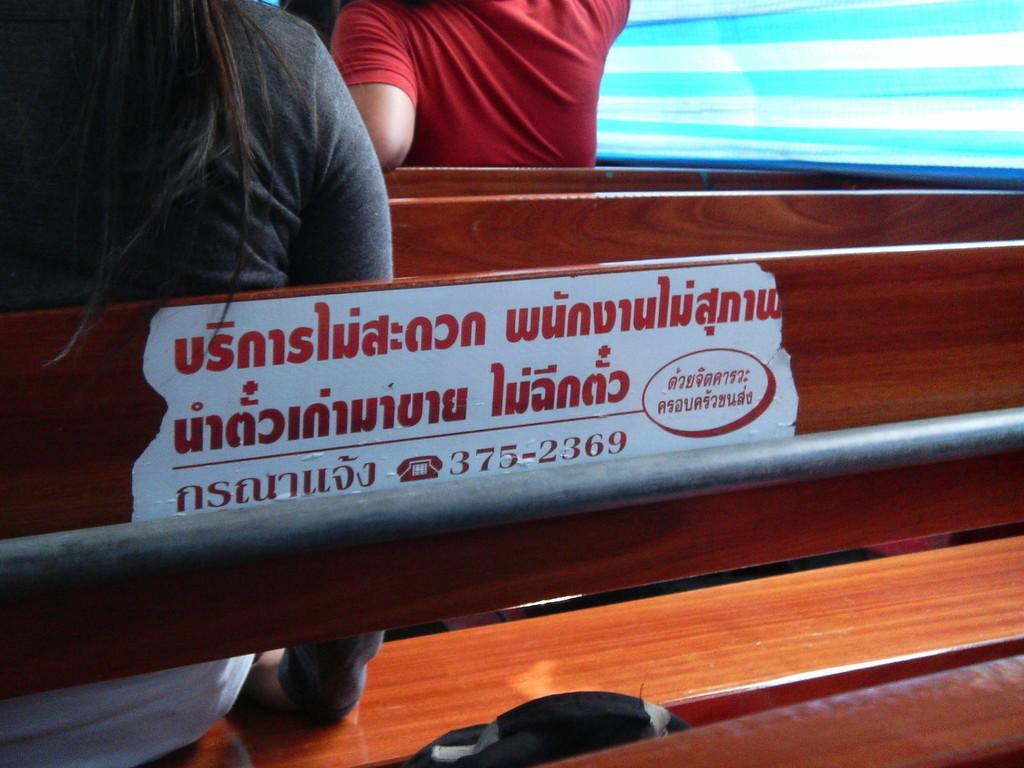Can you describe this image briefly? In this picture we can see few people are seated on the benches, and we can find a metal rod. 